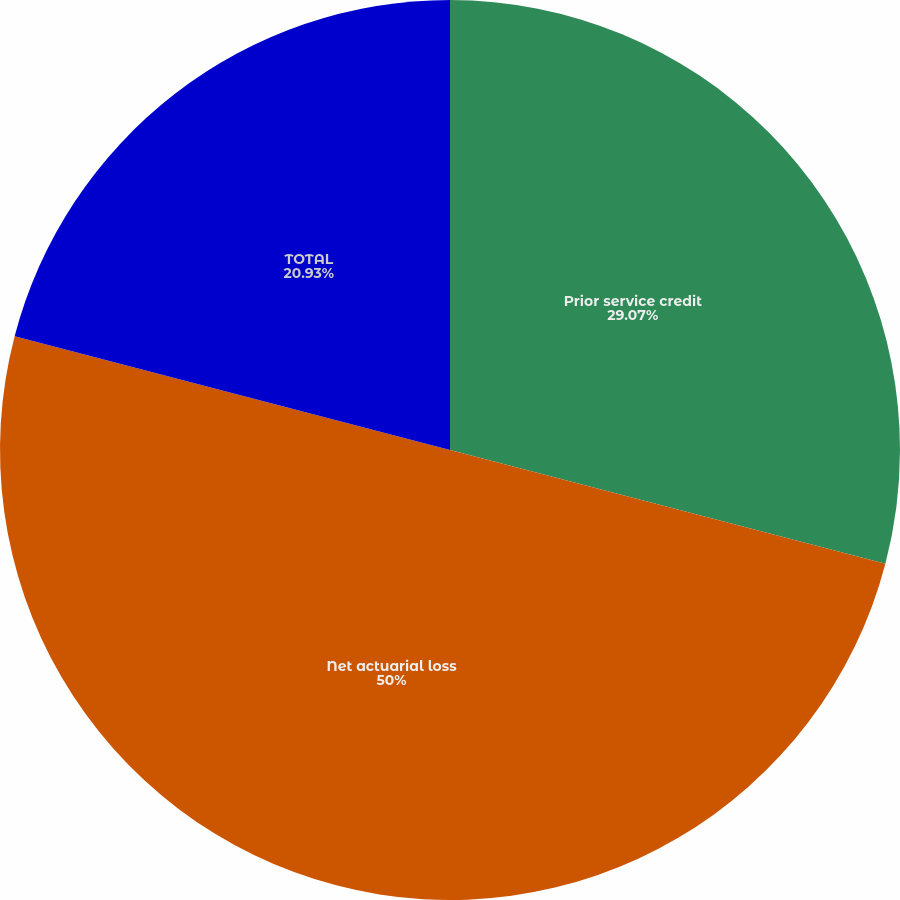<chart> <loc_0><loc_0><loc_500><loc_500><pie_chart><fcel>Prior service credit<fcel>Net actuarial loss<fcel>TOTAL<nl><fcel>29.07%<fcel>50.0%<fcel>20.93%<nl></chart> 